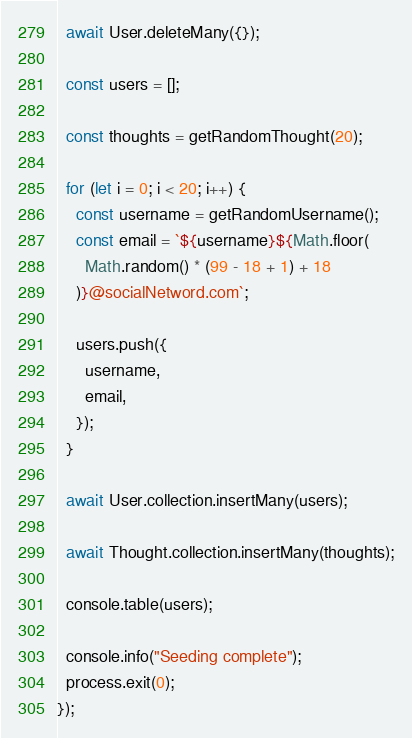<code> <loc_0><loc_0><loc_500><loc_500><_JavaScript_>  await User.deleteMany({});

  const users = [];

  const thoughts = getRandomThought(20);

  for (let i = 0; i < 20; i++) {
    const username = getRandomUsername();
    const email = `${username}${Math.floor(
      Math.random() * (99 - 18 + 1) + 18
    )}@socialNetword.com`;

    users.push({
      username,
      email,
    });
  }

  await User.collection.insertMany(users);

  await Thought.collection.insertMany(thoughts);

  console.table(users);

  console.info("Seeding complete");
  process.exit(0);
});
</code> 